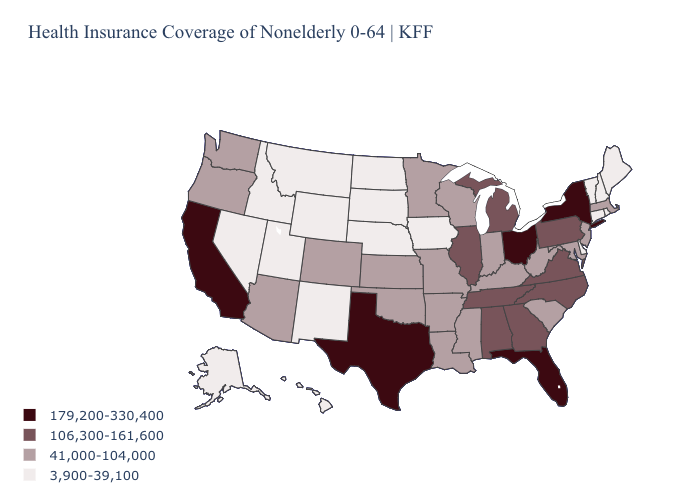What is the value of Alabama?
Keep it brief. 106,300-161,600. Name the states that have a value in the range 3,900-39,100?
Keep it brief. Alaska, Connecticut, Delaware, Hawaii, Idaho, Iowa, Maine, Montana, Nebraska, Nevada, New Hampshire, New Mexico, North Dakota, Rhode Island, South Dakota, Utah, Vermont, Wyoming. What is the highest value in states that border New York?
Be succinct. 106,300-161,600. Which states have the lowest value in the West?
Short answer required. Alaska, Hawaii, Idaho, Montana, Nevada, New Mexico, Utah, Wyoming. Is the legend a continuous bar?
Keep it brief. No. Does Ohio have the highest value in the MidWest?
Give a very brief answer. Yes. Does California have the highest value in the USA?
Give a very brief answer. Yes. How many symbols are there in the legend?
Be succinct. 4. What is the value of Texas?
Short answer required. 179,200-330,400. Name the states that have a value in the range 106,300-161,600?
Quick response, please. Alabama, Georgia, Illinois, Michigan, North Carolina, Pennsylvania, Tennessee, Virginia. Among the states that border Kansas , does Missouri have the lowest value?
Give a very brief answer. No. How many symbols are there in the legend?
Write a very short answer. 4. Among the states that border Virginia , which have the lowest value?
Be succinct. Kentucky, Maryland, West Virginia. Which states have the highest value in the USA?
Short answer required. California, Florida, New York, Ohio, Texas. What is the value of Alaska?
Quick response, please. 3,900-39,100. 